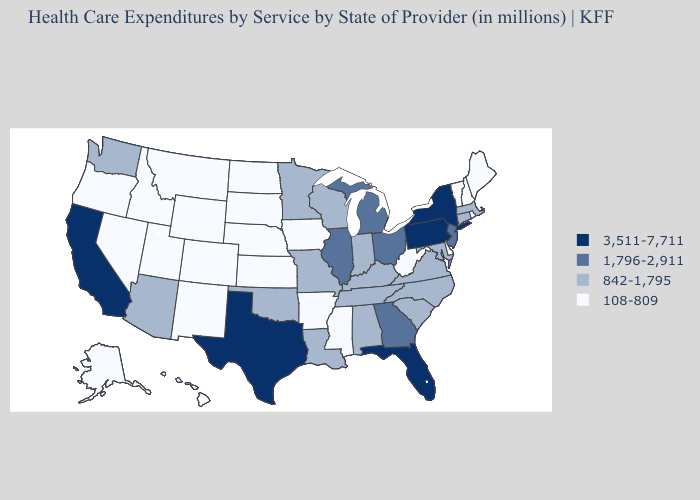Which states hav the highest value in the MidWest?
Concise answer only. Illinois, Michigan, Ohio. What is the lowest value in the South?
Write a very short answer. 108-809. Name the states that have a value in the range 842-1,795?
Short answer required. Alabama, Arizona, Connecticut, Indiana, Kentucky, Louisiana, Maryland, Massachusetts, Minnesota, Missouri, North Carolina, Oklahoma, South Carolina, Tennessee, Virginia, Washington, Wisconsin. Name the states that have a value in the range 3,511-7,711?
Keep it brief. California, Florida, New York, Pennsylvania, Texas. Among the states that border South Carolina , which have the highest value?
Be succinct. Georgia. Name the states that have a value in the range 3,511-7,711?
Quick response, please. California, Florida, New York, Pennsylvania, Texas. Does Nevada have a lower value than Washington?
Answer briefly. Yes. What is the lowest value in states that border Mississippi?
Concise answer only. 108-809. Name the states that have a value in the range 1,796-2,911?
Write a very short answer. Georgia, Illinois, Michigan, New Jersey, Ohio. Name the states that have a value in the range 842-1,795?
Write a very short answer. Alabama, Arizona, Connecticut, Indiana, Kentucky, Louisiana, Maryland, Massachusetts, Minnesota, Missouri, North Carolina, Oklahoma, South Carolina, Tennessee, Virginia, Washington, Wisconsin. Which states hav the highest value in the West?
Keep it brief. California. Does Kansas have the highest value in the USA?
Answer briefly. No. Name the states that have a value in the range 1,796-2,911?
Short answer required. Georgia, Illinois, Michigan, New Jersey, Ohio. Among the states that border Iowa , which have the highest value?
Keep it brief. Illinois. Among the states that border Kentucky , which have the lowest value?
Give a very brief answer. West Virginia. 